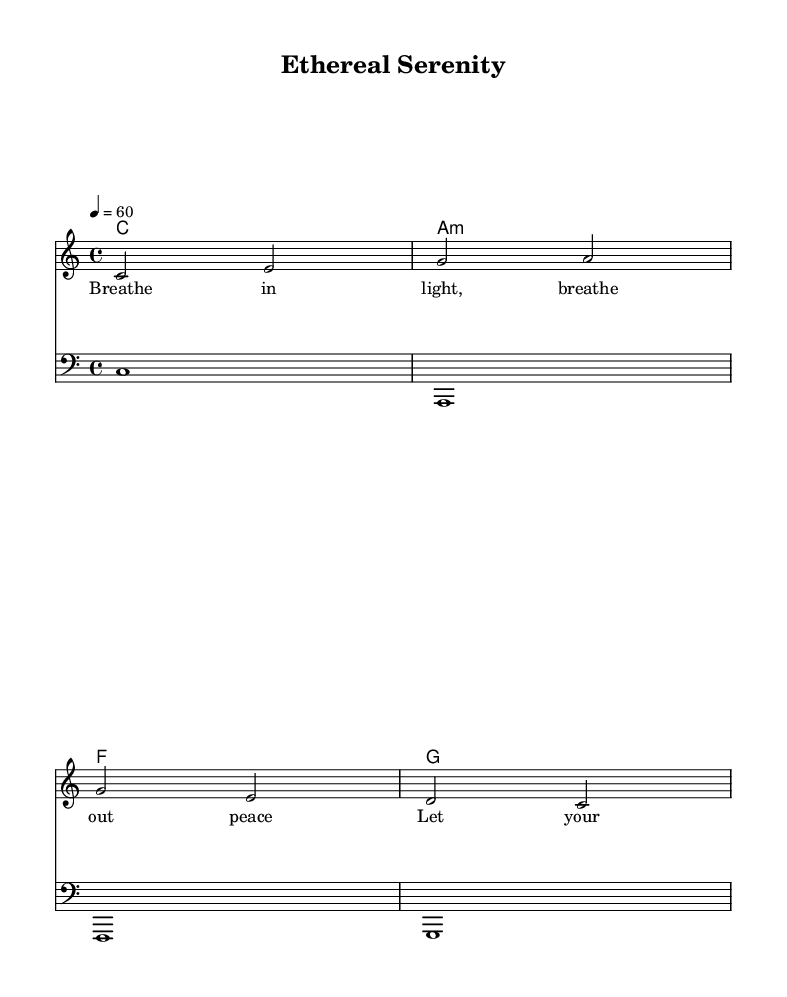What is the key signature of this music? The key signature is C major, which has no sharps or flats.
Answer: C major What is the time signature of this piece? The time signature is indicated at the beginning of the music as 4/4, meaning there are four beats in each measure.
Answer: 4/4 What is the tempo marking of the piece? The tempo marking indicates a speed of 60 beats per minute, showing the pace at which the music should be played.
Answer: 60 What is the highest note in the melody? The highest note in the given melody part is A, which is a third above the C note at the beginning.
Answer: A How many measures are in the score? The score consists of four measures, which can be counted visually based on the grouping of the notes and rests.
Answer: 4 What type of electronic music is represented in this sheet? The music is characterized as gentle electronic hymns and chants, often used for meditation or inner peace.
Answer: Gentle electronic hymns What chords are used in the harmonies? The chords used in the harmonies include C major, A minor, F major, and G major, which provide a soothing backdrop to the melody.
Answer: C, A minor, F, G 